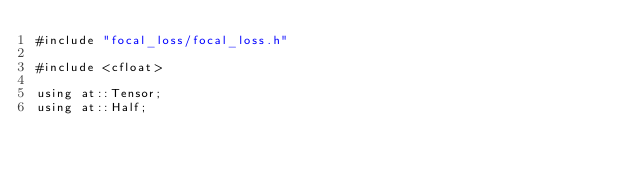Convert code to text. <code><loc_0><loc_0><loc_500><loc_500><_Cuda_>#include "focal_loss/focal_loss.h"

#include <cfloat>

using at::Tensor;
using at::Half;
</code> 